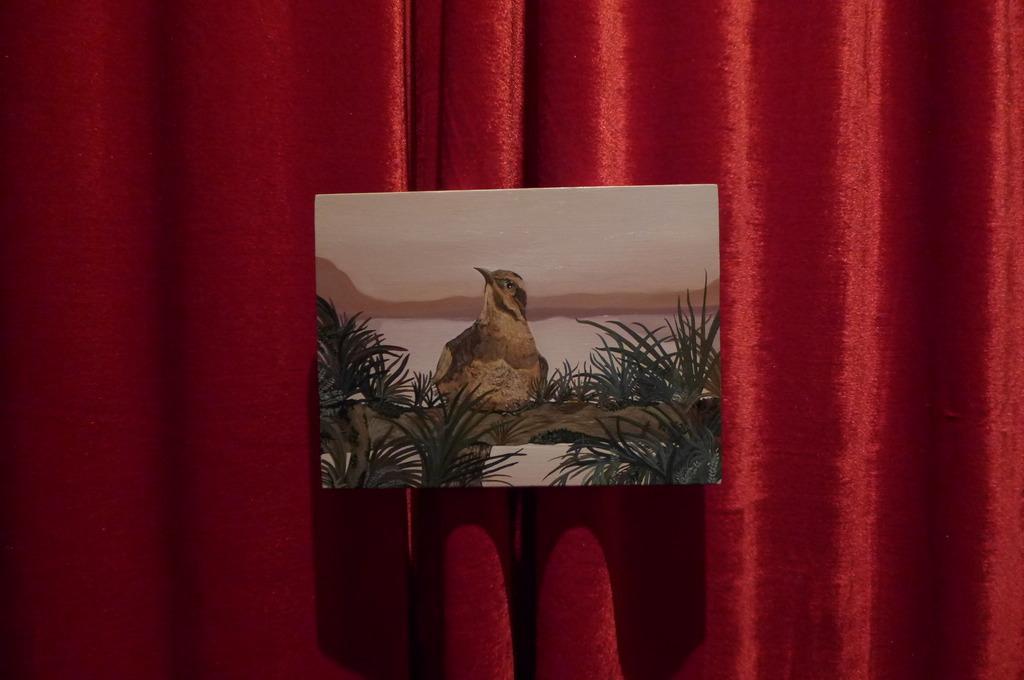How would you summarize this image in a sentence or two? In this picture we have a painting of a bird and grass in front of a red curtain. 